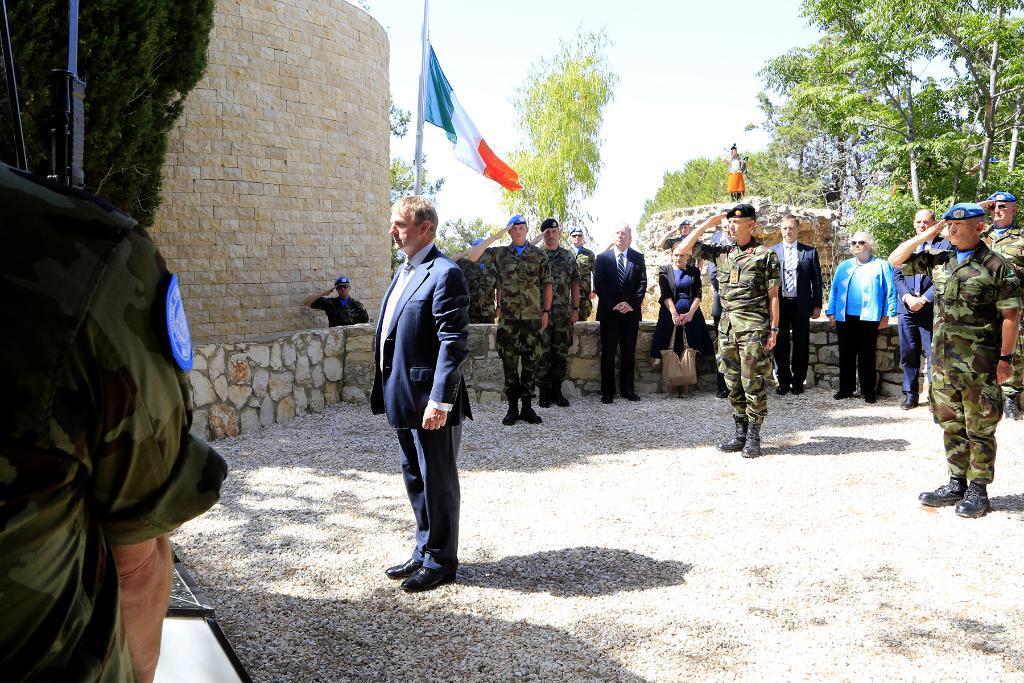Please provide a concise description of this image. In this image we can see many people. We can see a person at the left side of the image. There is a plant in the image. There is a flag in the image. There is a rock wall in the image. We can see the sky in the image. There are few trees in the image. 